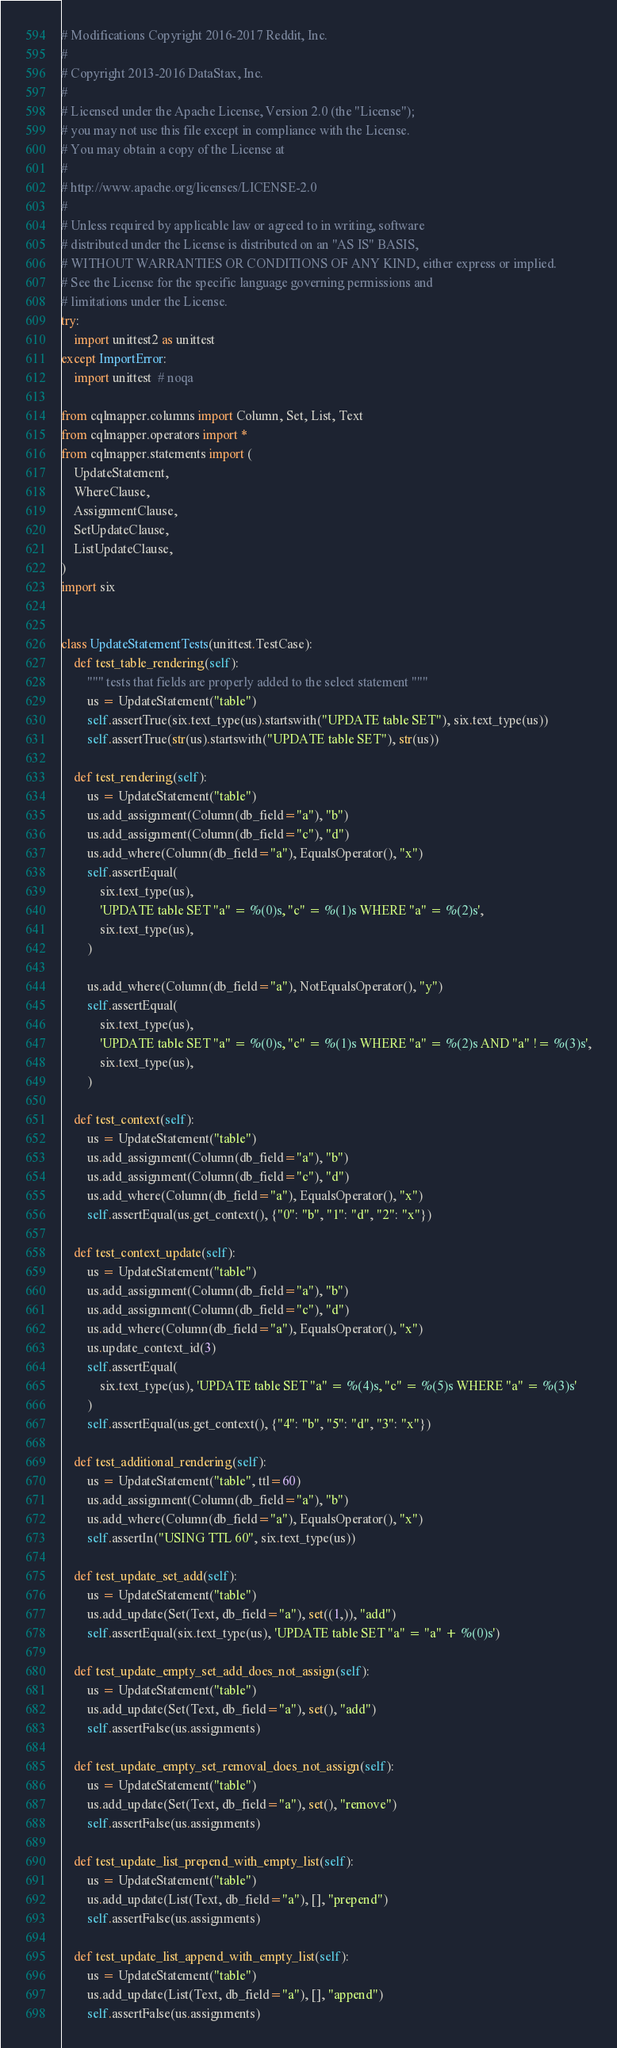Convert code to text. <code><loc_0><loc_0><loc_500><loc_500><_Python_># Modifications Copyright 2016-2017 Reddit, Inc.
#
# Copyright 2013-2016 DataStax, Inc.
#
# Licensed under the Apache License, Version 2.0 (the "License");
# you may not use this file except in compliance with the License.
# You may obtain a copy of the License at
#
# http://www.apache.org/licenses/LICENSE-2.0
#
# Unless required by applicable law or agreed to in writing, software
# distributed under the License is distributed on an "AS IS" BASIS,
# WITHOUT WARRANTIES OR CONDITIONS OF ANY KIND, either express or implied.
# See the License for the specific language governing permissions and
# limitations under the License.
try:
    import unittest2 as unittest
except ImportError:
    import unittest  # noqa

from cqlmapper.columns import Column, Set, List, Text
from cqlmapper.operators import *
from cqlmapper.statements import (
    UpdateStatement,
    WhereClause,
    AssignmentClause,
    SetUpdateClause,
    ListUpdateClause,
)
import six


class UpdateStatementTests(unittest.TestCase):
    def test_table_rendering(self):
        """ tests that fields are properly added to the select statement """
        us = UpdateStatement("table")
        self.assertTrue(six.text_type(us).startswith("UPDATE table SET"), six.text_type(us))
        self.assertTrue(str(us).startswith("UPDATE table SET"), str(us))

    def test_rendering(self):
        us = UpdateStatement("table")
        us.add_assignment(Column(db_field="a"), "b")
        us.add_assignment(Column(db_field="c"), "d")
        us.add_where(Column(db_field="a"), EqualsOperator(), "x")
        self.assertEqual(
            six.text_type(us),
            'UPDATE table SET "a" = %(0)s, "c" = %(1)s WHERE "a" = %(2)s',
            six.text_type(us),
        )

        us.add_where(Column(db_field="a"), NotEqualsOperator(), "y")
        self.assertEqual(
            six.text_type(us),
            'UPDATE table SET "a" = %(0)s, "c" = %(1)s WHERE "a" = %(2)s AND "a" != %(3)s',
            six.text_type(us),
        )

    def test_context(self):
        us = UpdateStatement("table")
        us.add_assignment(Column(db_field="a"), "b")
        us.add_assignment(Column(db_field="c"), "d")
        us.add_where(Column(db_field="a"), EqualsOperator(), "x")
        self.assertEqual(us.get_context(), {"0": "b", "1": "d", "2": "x"})

    def test_context_update(self):
        us = UpdateStatement("table")
        us.add_assignment(Column(db_field="a"), "b")
        us.add_assignment(Column(db_field="c"), "d")
        us.add_where(Column(db_field="a"), EqualsOperator(), "x")
        us.update_context_id(3)
        self.assertEqual(
            six.text_type(us), 'UPDATE table SET "a" = %(4)s, "c" = %(5)s WHERE "a" = %(3)s'
        )
        self.assertEqual(us.get_context(), {"4": "b", "5": "d", "3": "x"})

    def test_additional_rendering(self):
        us = UpdateStatement("table", ttl=60)
        us.add_assignment(Column(db_field="a"), "b")
        us.add_where(Column(db_field="a"), EqualsOperator(), "x")
        self.assertIn("USING TTL 60", six.text_type(us))

    def test_update_set_add(self):
        us = UpdateStatement("table")
        us.add_update(Set(Text, db_field="a"), set((1,)), "add")
        self.assertEqual(six.text_type(us), 'UPDATE table SET "a" = "a" + %(0)s')

    def test_update_empty_set_add_does_not_assign(self):
        us = UpdateStatement("table")
        us.add_update(Set(Text, db_field="a"), set(), "add")
        self.assertFalse(us.assignments)

    def test_update_empty_set_removal_does_not_assign(self):
        us = UpdateStatement("table")
        us.add_update(Set(Text, db_field="a"), set(), "remove")
        self.assertFalse(us.assignments)

    def test_update_list_prepend_with_empty_list(self):
        us = UpdateStatement("table")
        us.add_update(List(Text, db_field="a"), [], "prepend")
        self.assertFalse(us.assignments)

    def test_update_list_append_with_empty_list(self):
        us = UpdateStatement("table")
        us.add_update(List(Text, db_field="a"), [], "append")
        self.assertFalse(us.assignments)
</code> 